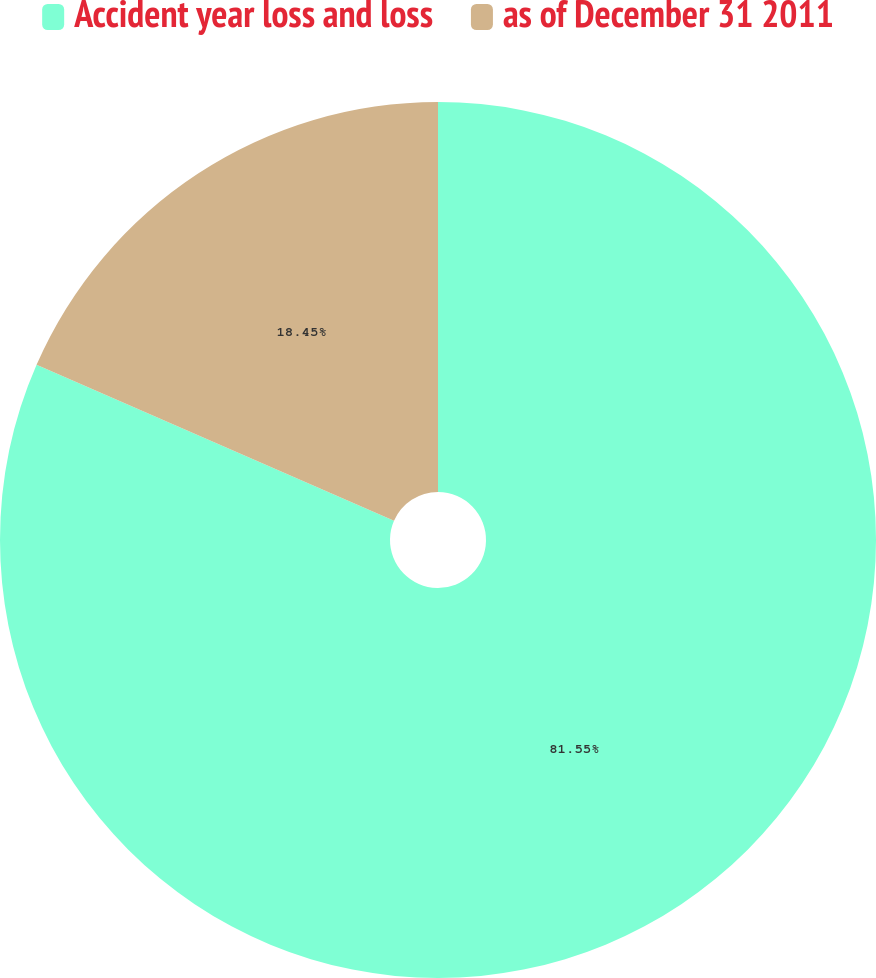Convert chart. <chart><loc_0><loc_0><loc_500><loc_500><pie_chart><fcel>Accident year loss and loss<fcel>as of December 31 2011<nl><fcel>81.55%<fcel>18.45%<nl></chart> 